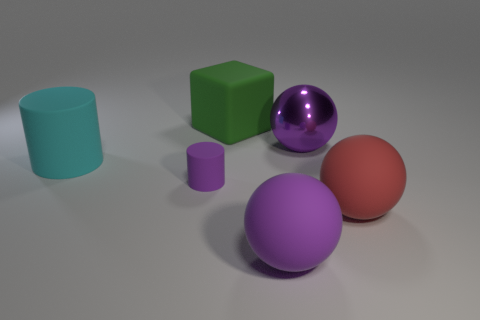Add 3 large purple rubber things. How many objects exist? 9 Subtract all cylinders. How many objects are left? 4 Add 6 tiny purple rubber things. How many tiny purple rubber things are left? 7 Add 5 small rubber cylinders. How many small rubber cylinders exist? 6 Subtract 0 red cylinders. How many objects are left? 6 Subtract all tiny green metal things. Subtract all big rubber objects. How many objects are left? 2 